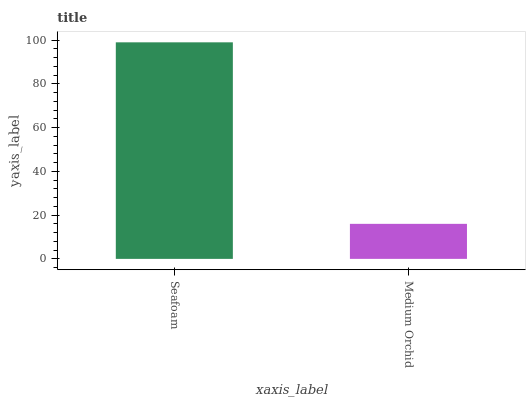Is Medium Orchid the minimum?
Answer yes or no. Yes. Is Seafoam the maximum?
Answer yes or no. Yes. Is Medium Orchid the maximum?
Answer yes or no. No. Is Seafoam greater than Medium Orchid?
Answer yes or no. Yes. Is Medium Orchid less than Seafoam?
Answer yes or no. Yes. Is Medium Orchid greater than Seafoam?
Answer yes or no. No. Is Seafoam less than Medium Orchid?
Answer yes or no. No. Is Seafoam the high median?
Answer yes or no. Yes. Is Medium Orchid the low median?
Answer yes or no. Yes. Is Medium Orchid the high median?
Answer yes or no. No. Is Seafoam the low median?
Answer yes or no. No. 